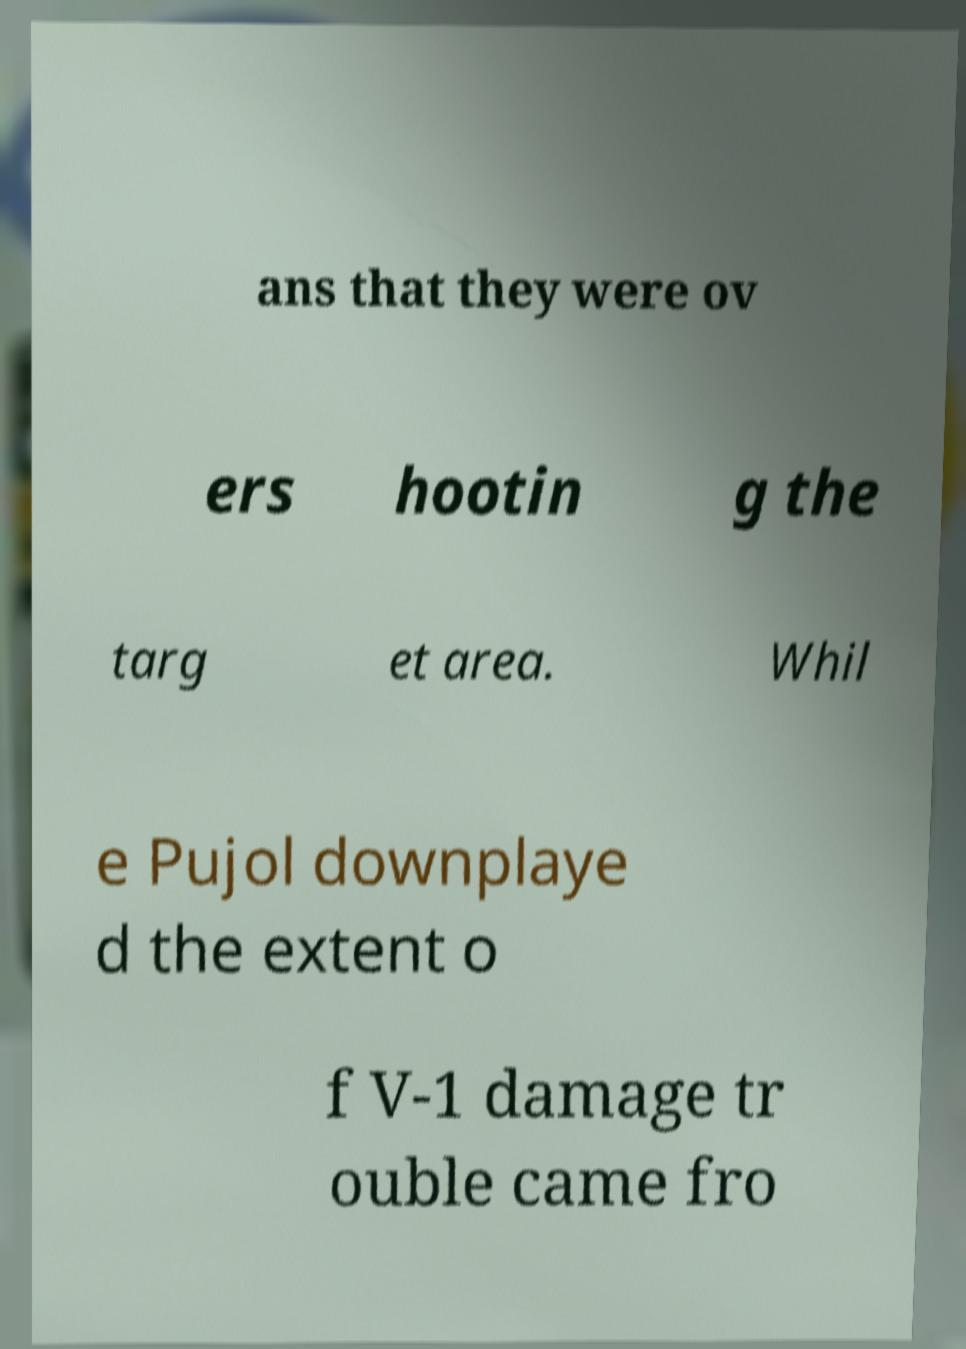For documentation purposes, I need the text within this image transcribed. Could you provide that? ans that they were ov ers hootin g the targ et area. Whil e Pujol downplaye d the extent o f V-1 damage tr ouble came fro 